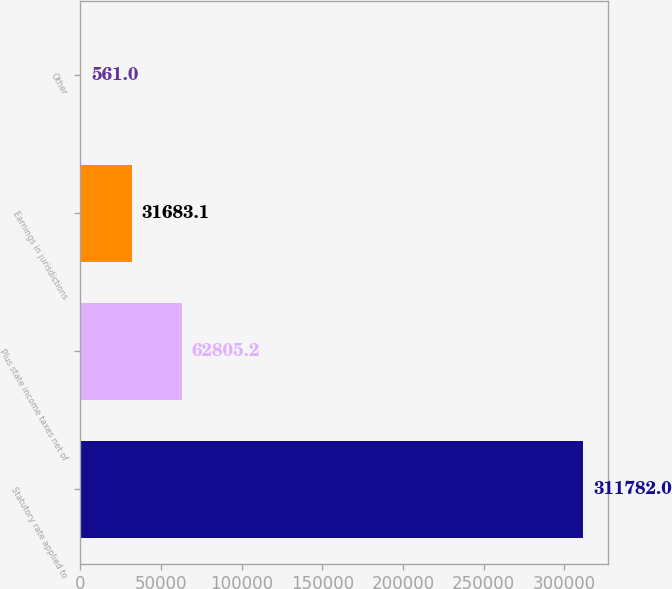<chart> <loc_0><loc_0><loc_500><loc_500><bar_chart><fcel>Statutory rate applied to<fcel>Plus state income taxes net of<fcel>Earnings in jurisdictions<fcel>Other<nl><fcel>311782<fcel>62805.2<fcel>31683.1<fcel>561<nl></chart> 